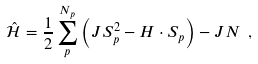Convert formula to latex. <formula><loc_0><loc_0><loc_500><loc_500>\hat { \mathcal { H } } = \frac { 1 } { 2 } \sum _ { p } ^ { N _ { p } } \left ( J { S } _ { p } ^ { 2 } - { H } \cdot { S } _ { p } \right ) - J N \ ,</formula> 